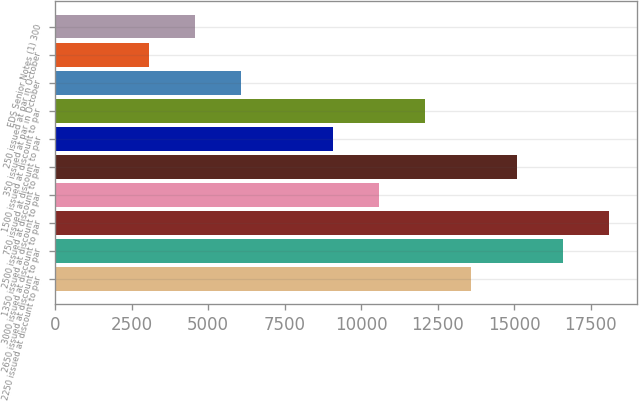<chart> <loc_0><loc_0><loc_500><loc_500><bar_chart><fcel>2250 issued at discount to par<fcel>2650 issued at discount to par<fcel>3000 issued at discount to par<fcel>1350 issued at discount to par<fcel>2500 issued at discount to par<fcel>750 issued at discount to par<fcel>1500 issued at discount to par<fcel>350 issued at par in October<fcel>250 issued at par in October<fcel>EDS Senior Notes (1) 300<nl><fcel>13598.2<fcel>16607.8<fcel>18112.6<fcel>10588.6<fcel>15103<fcel>9083.8<fcel>12093.4<fcel>6074.2<fcel>3064.6<fcel>4569.4<nl></chart> 